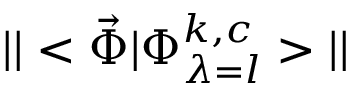<formula> <loc_0><loc_0><loc_500><loc_500>| | < \vec { \Phi } | \Phi _ { \lambda = l } ^ { k , c } > | |</formula> 